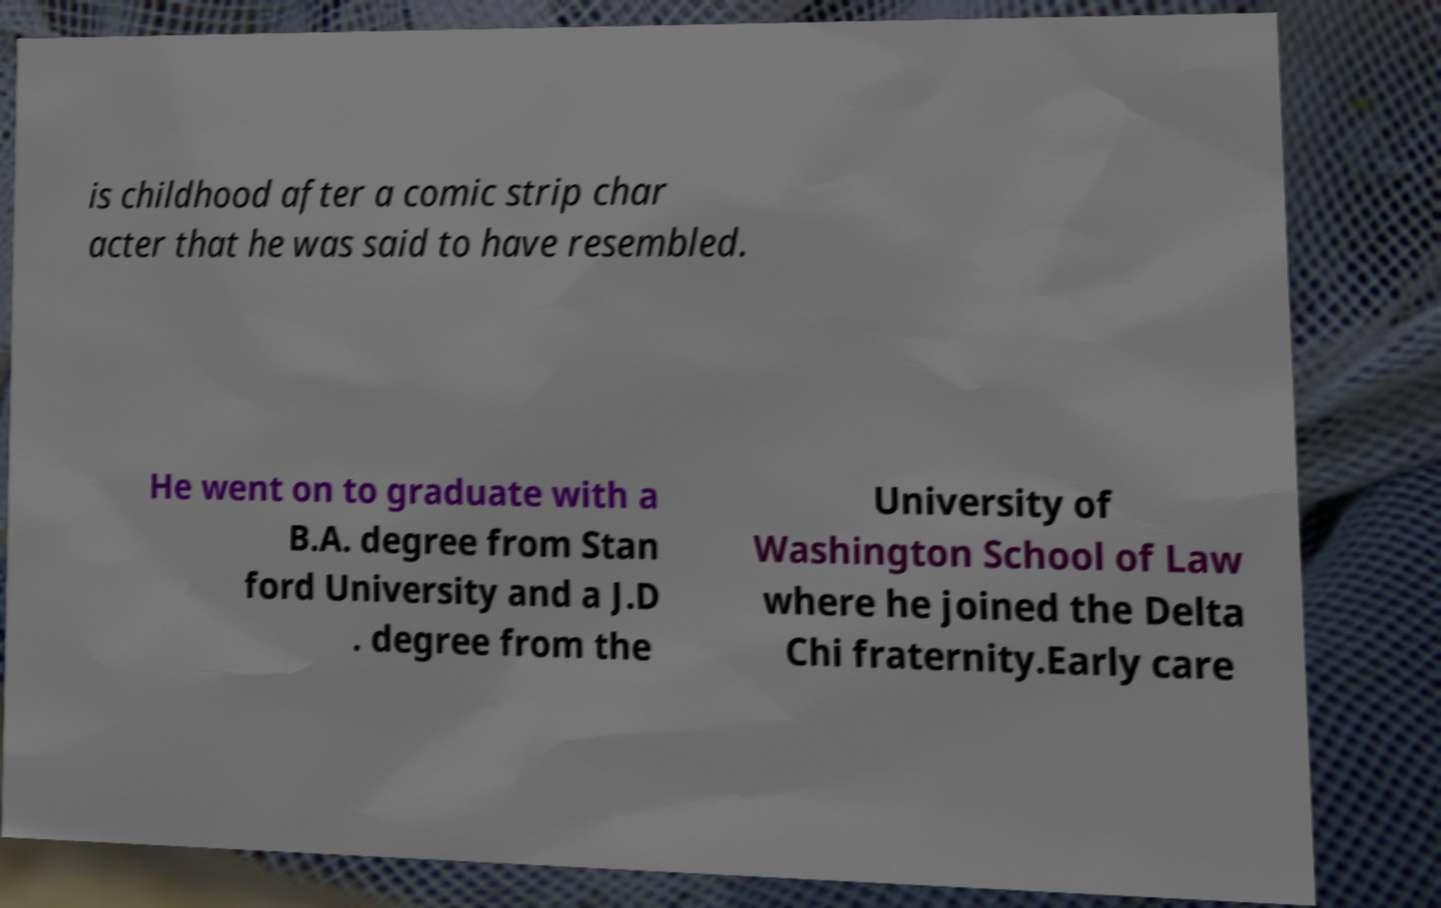Please read and relay the text visible in this image. What does it say? is childhood after a comic strip char acter that he was said to have resembled. He went on to graduate with a B.A. degree from Stan ford University and a J.D . degree from the University of Washington School of Law where he joined the Delta Chi fraternity.Early care 